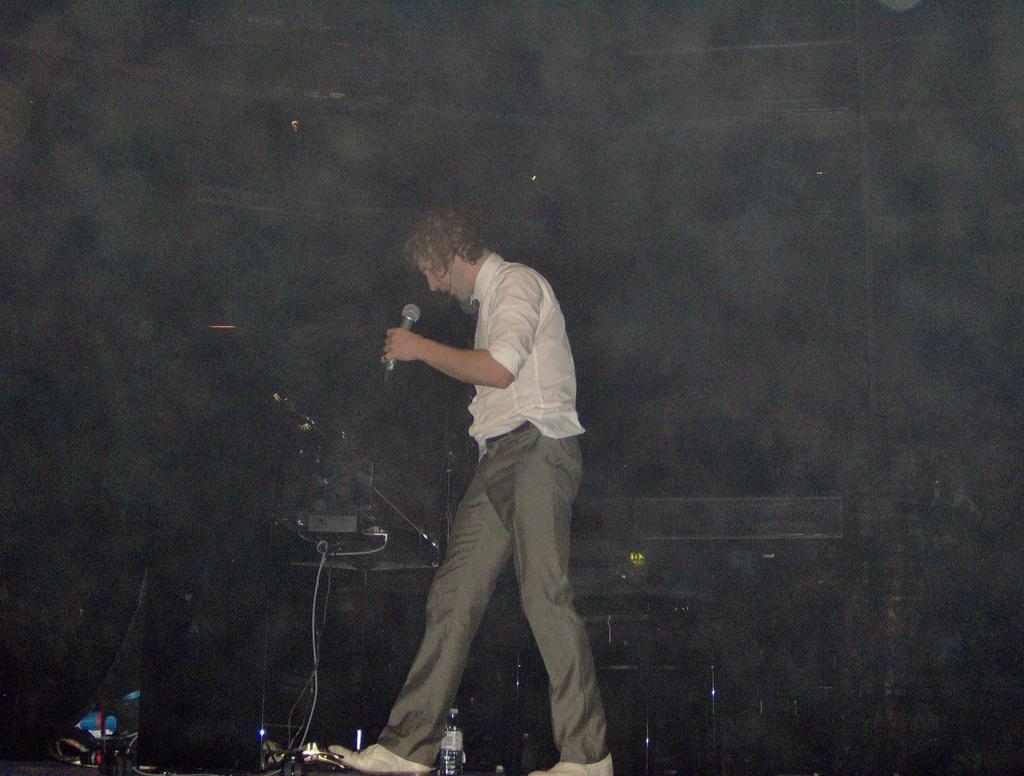Who is the main subject in the image? There is a man in the image. What is the man holding in the image? The man is holding a mic. What else can be seen in the image besides the man and the mic? There is a bottle, wires, and some objects in the image. Can you describe the background of the image? The background of the image is dark. What type of behavior does the grandfather exhibit in the image? There is no grandfather present in the image, and therefore no behavior can be observed. In which direction is the man facing in the image? The provided facts do not specify the direction the man is facing in the image. 